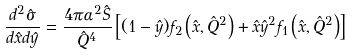Convert formula to latex. <formula><loc_0><loc_0><loc_500><loc_500>\frac { d ^ { 2 } \hat { \sigma } } { d \hat { x } d \hat { y } } = \frac { 4 \pi \alpha ^ { 2 } \hat { S } } { { \hat { Q } } ^ { 4 } } \left [ ( 1 - { \hat { y } } ) f _ { 2 } \left ( { \hat { x } } , { \hat { Q } } ^ { 2 } \right ) + { \hat { x } } { \hat { y } } ^ { 2 } f _ { 1 } \left ( { \hat { x } } , { \hat { Q } } ^ { 2 } \right ) \right ]</formula> 